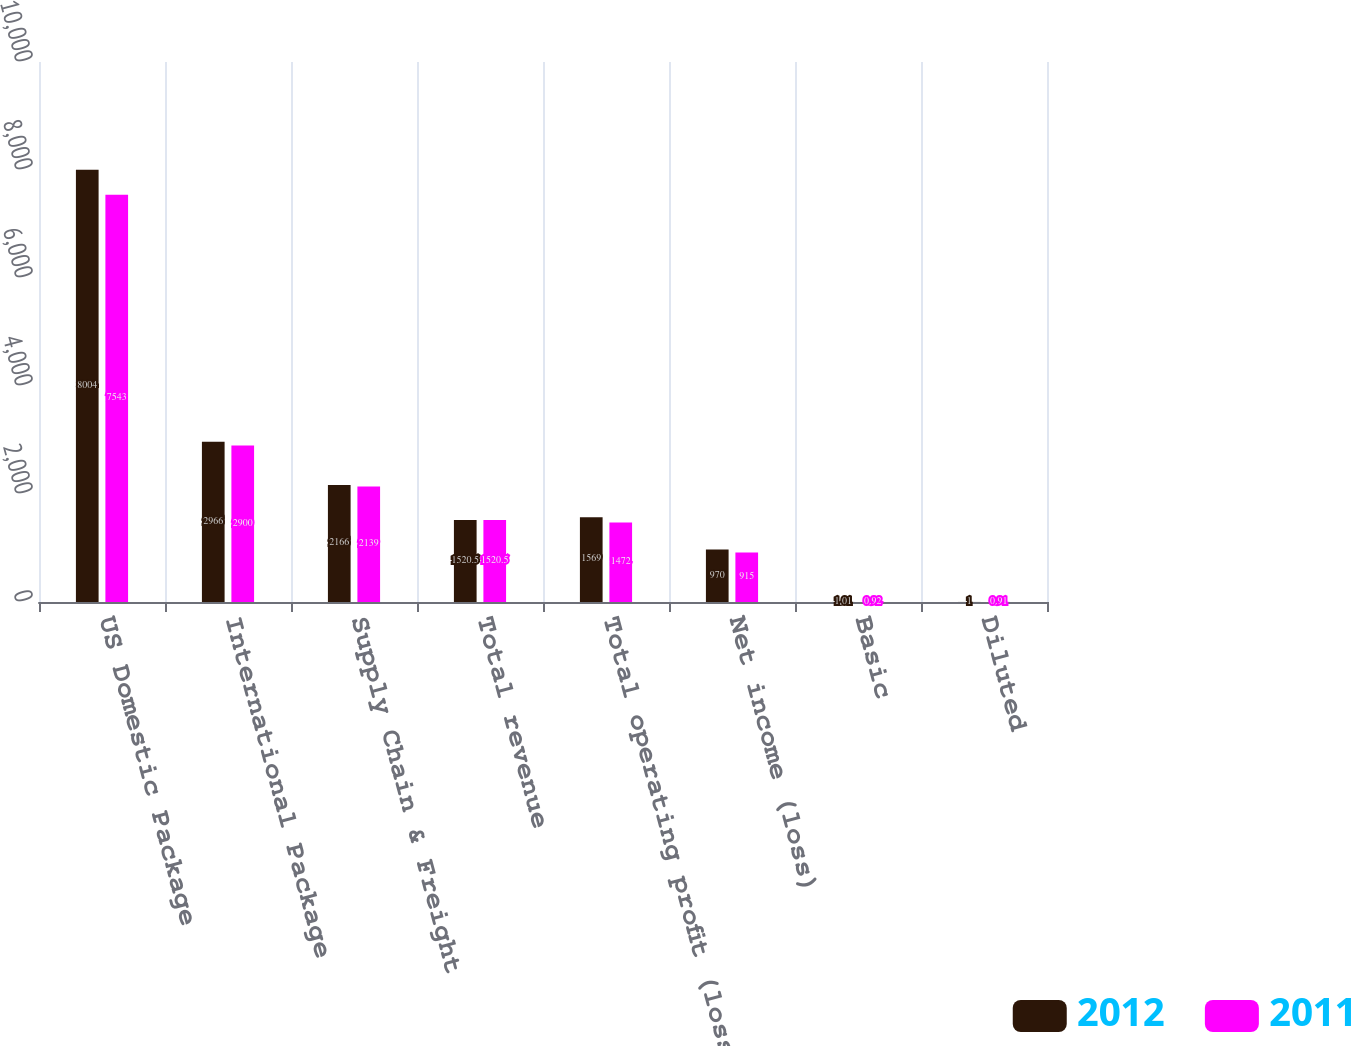<chart> <loc_0><loc_0><loc_500><loc_500><stacked_bar_chart><ecel><fcel>US Domestic Package<fcel>International Package<fcel>Supply Chain & Freight<fcel>Total revenue<fcel>Total operating profit (loss)<fcel>Net income (loss)<fcel>Basic<fcel>Diluted<nl><fcel>2012<fcel>8004<fcel>2966<fcel>2166<fcel>1520.5<fcel>1569<fcel>970<fcel>1.01<fcel>1<nl><fcel>2011<fcel>7543<fcel>2900<fcel>2139<fcel>1520.5<fcel>1472<fcel>915<fcel>0.92<fcel>0.91<nl></chart> 